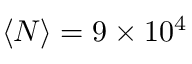<formula> <loc_0><loc_0><loc_500><loc_500>\langle N \rangle = 9 \times 1 0 ^ { 4 }</formula> 